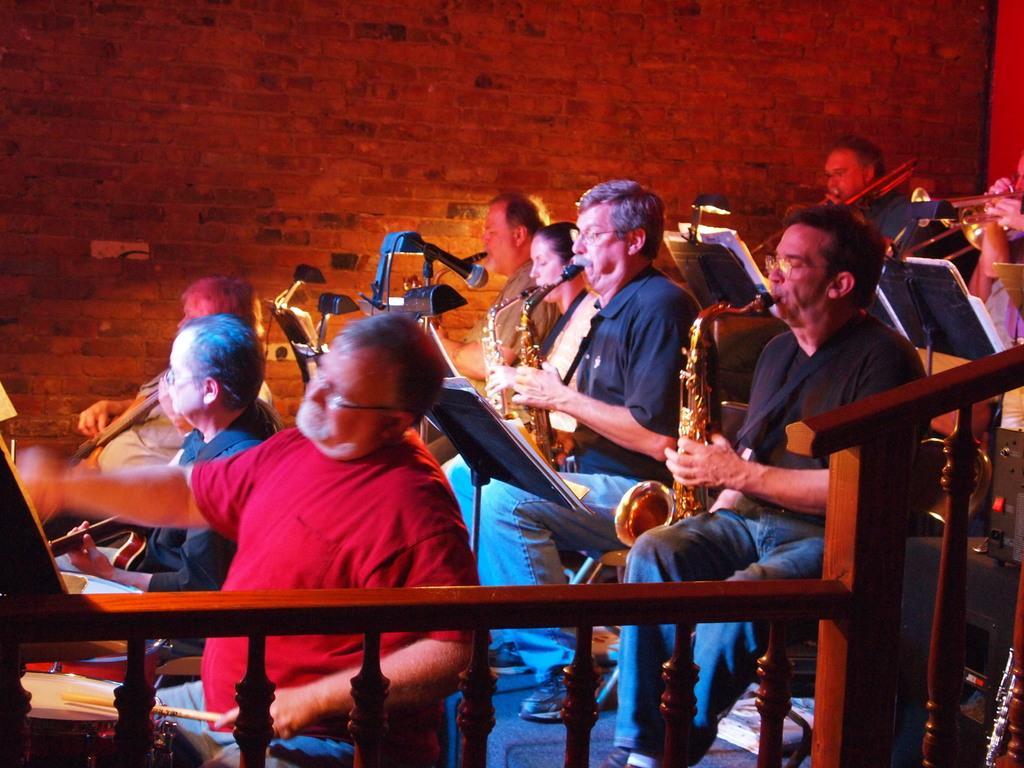Can you describe this image briefly? In the picture we can see some people are sitting on the chairs and playing a musical instrument and beside them, we can see a railing and in the background we can see a wall with bricks. 